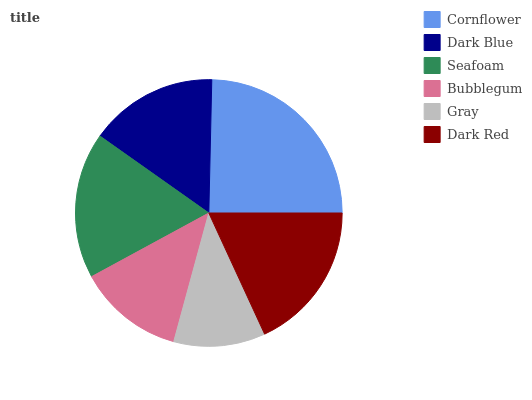Is Gray the minimum?
Answer yes or no. Yes. Is Cornflower the maximum?
Answer yes or no. Yes. Is Dark Blue the minimum?
Answer yes or no. No. Is Dark Blue the maximum?
Answer yes or no. No. Is Cornflower greater than Dark Blue?
Answer yes or no. Yes. Is Dark Blue less than Cornflower?
Answer yes or no. Yes. Is Dark Blue greater than Cornflower?
Answer yes or no. No. Is Cornflower less than Dark Blue?
Answer yes or no. No. Is Seafoam the high median?
Answer yes or no. Yes. Is Dark Blue the low median?
Answer yes or no. Yes. Is Cornflower the high median?
Answer yes or no. No. Is Seafoam the low median?
Answer yes or no. No. 